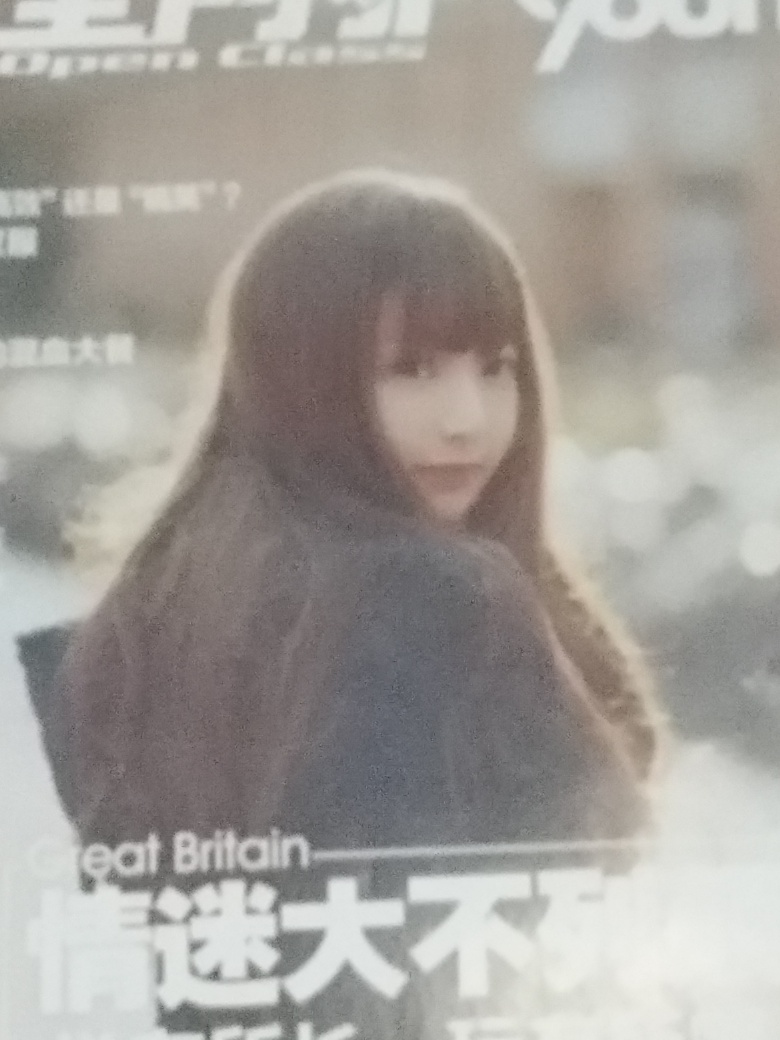How do you think the elements in the image contribute to its overall mood? Various elements in this image coalesce to create a poignant mood. The soft focus suggests a fleeting moment captured in time or a memory. The grainy texture adds a sense of raw authenticity, as if the scene is untouched by digital alteration, preserving the genuine essence of the moment. The natural light and monochromatic tones further establish a solemn, somewhat melancholic atmosphere that envelops the subject. 